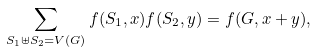Convert formula to latex. <formula><loc_0><loc_0><loc_500><loc_500>\sum _ { S _ { 1 } \uplus S _ { 2 } = V ( G ) } f ( S _ { 1 } , x ) f ( S _ { 2 } , y ) = f ( G , x + y ) ,</formula> 